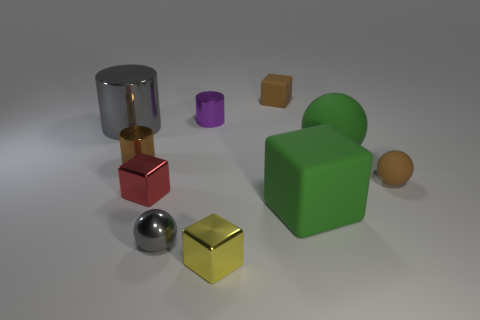What number of things are the same color as the tiny rubber ball?
Your answer should be compact. 2. Is there a green rubber sphere that has the same size as the brown ball?
Make the answer very short. No. There is a yellow object that is the same size as the brown metallic cylinder; what is it made of?
Ensure brevity in your answer.  Metal. What number of gray matte things are there?
Give a very brief answer. 0. What is the size of the shiny cylinder to the right of the red block?
Ensure brevity in your answer.  Small. Are there an equal number of shiny objects that are in front of the big shiny cylinder and small gray matte cubes?
Make the answer very short. No. Is there a tiny blue metallic object of the same shape as the tiny purple metal thing?
Your response must be concise. No. What shape is the metal thing that is in front of the tiny purple metallic object and behind the big green rubber ball?
Make the answer very short. Cylinder. Do the small yellow cube and the gray thing behind the gray sphere have the same material?
Your answer should be very brief. Yes. Are there any purple cylinders to the right of the tiny brown metal cylinder?
Provide a succinct answer. Yes. 